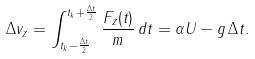<formula> <loc_0><loc_0><loc_500><loc_500>\Delta v _ { z } = \int _ { t _ { k } - \frac { \Delta t } { 2 } } ^ { t _ { k } + \frac { \Delta t } { 2 } } \frac { F _ { z } ( t ) } { m } \, d t = \alpha U - g \, \Delta t .</formula> 